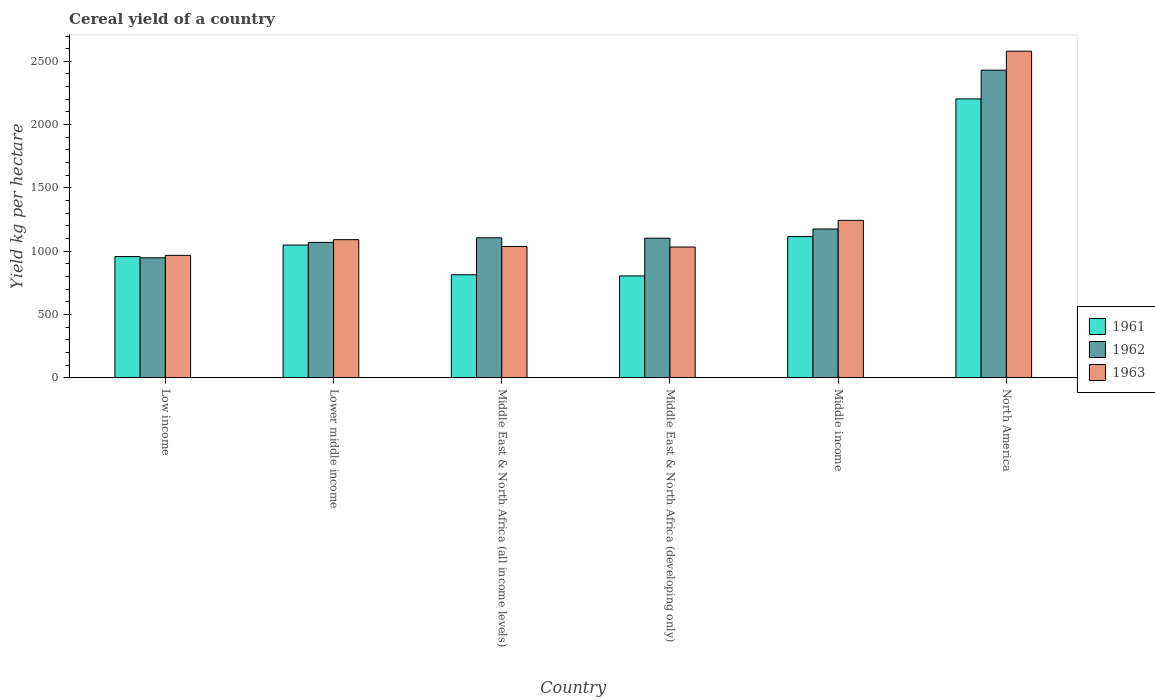How many groups of bars are there?
Give a very brief answer. 6. In how many cases, is the number of bars for a given country not equal to the number of legend labels?
Your answer should be very brief. 0. What is the total cereal yield in 1961 in Lower middle income?
Provide a succinct answer. 1048.21. Across all countries, what is the maximum total cereal yield in 1963?
Your response must be concise. 2580.19. Across all countries, what is the minimum total cereal yield in 1963?
Make the answer very short. 966.74. In which country was the total cereal yield in 1961 maximum?
Provide a short and direct response. North America. In which country was the total cereal yield in 1963 minimum?
Offer a terse response. Low income. What is the total total cereal yield in 1962 in the graph?
Offer a terse response. 7829.41. What is the difference between the total cereal yield in 1961 in Middle East & North Africa (all income levels) and that in North America?
Your answer should be very brief. -1390.13. What is the difference between the total cereal yield in 1962 in Middle income and the total cereal yield in 1963 in Middle East & North Africa (developing only)?
Provide a succinct answer. 142.79. What is the average total cereal yield in 1963 per country?
Your answer should be very brief. 1325.02. What is the difference between the total cereal yield of/in 1963 and total cereal yield of/in 1961 in North America?
Ensure brevity in your answer.  376.9. In how many countries, is the total cereal yield in 1963 greater than 200 kg per hectare?
Give a very brief answer. 6. What is the ratio of the total cereal yield in 1961 in Lower middle income to that in Middle East & North Africa (developing only)?
Offer a very short reply. 1.3. Is the difference between the total cereal yield in 1963 in Middle East & North Africa (all income levels) and North America greater than the difference between the total cereal yield in 1961 in Middle East & North Africa (all income levels) and North America?
Provide a short and direct response. No. What is the difference between the highest and the second highest total cereal yield in 1963?
Keep it short and to the point. -152.61. What is the difference between the highest and the lowest total cereal yield in 1963?
Give a very brief answer. 1613.45. In how many countries, is the total cereal yield in 1962 greater than the average total cereal yield in 1962 taken over all countries?
Your answer should be very brief. 1. Is the sum of the total cereal yield in 1963 in Low income and Middle East & North Africa (developing only) greater than the maximum total cereal yield in 1962 across all countries?
Offer a terse response. No. What does the 1st bar from the right in North America represents?
Offer a terse response. 1963. Is it the case that in every country, the sum of the total cereal yield in 1963 and total cereal yield in 1961 is greater than the total cereal yield in 1962?
Your response must be concise. Yes. How many bars are there?
Keep it short and to the point. 18. Are all the bars in the graph horizontal?
Ensure brevity in your answer.  No. How many countries are there in the graph?
Ensure brevity in your answer.  6. Are the values on the major ticks of Y-axis written in scientific E-notation?
Offer a very short reply. No. Does the graph contain grids?
Make the answer very short. No. What is the title of the graph?
Offer a very short reply. Cereal yield of a country. What is the label or title of the X-axis?
Keep it short and to the point. Country. What is the label or title of the Y-axis?
Give a very brief answer. Yield kg per hectare. What is the Yield kg per hectare in 1961 in Low income?
Keep it short and to the point. 956.88. What is the Yield kg per hectare of 1962 in Low income?
Your answer should be very brief. 947.28. What is the Yield kg per hectare of 1963 in Low income?
Offer a very short reply. 966.74. What is the Yield kg per hectare in 1961 in Lower middle income?
Provide a succinct answer. 1048.21. What is the Yield kg per hectare in 1962 in Lower middle income?
Provide a short and direct response. 1069.15. What is the Yield kg per hectare in 1963 in Lower middle income?
Provide a succinct answer. 1090.7. What is the Yield kg per hectare of 1961 in Middle East & North Africa (all income levels)?
Keep it short and to the point. 813.16. What is the Yield kg per hectare in 1962 in Middle East & North Africa (all income levels)?
Make the answer very short. 1105.39. What is the Yield kg per hectare of 1963 in Middle East & North Africa (all income levels)?
Provide a succinct answer. 1036.88. What is the Yield kg per hectare in 1961 in Middle East & North Africa (developing only)?
Offer a very short reply. 804.16. What is the Yield kg per hectare of 1962 in Middle East & North Africa (developing only)?
Your answer should be very brief. 1102.28. What is the Yield kg per hectare of 1963 in Middle East & North Africa (developing only)?
Your response must be concise. 1032.31. What is the Yield kg per hectare in 1961 in Middle income?
Provide a short and direct response. 1114.95. What is the Yield kg per hectare of 1962 in Middle income?
Offer a very short reply. 1175.1. What is the Yield kg per hectare of 1963 in Middle income?
Keep it short and to the point. 1243.31. What is the Yield kg per hectare in 1961 in North America?
Offer a terse response. 2203.29. What is the Yield kg per hectare in 1962 in North America?
Provide a short and direct response. 2430.22. What is the Yield kg per hectare of 1963 in North America?
Provide a succinct answer. 2580.19. Across all countries, what is the maximum Yield kg per hectare of 1961?
Your response must be concise. 2203.29. Across all countries, what is the maximum Yield kg per hectare in 1962?
Provide a succinct answer. 2430.22. Across all countries, what is the maximum Yield kg per hectare in 1963?
Your answer should be very brief. 2580.19. Across all countries, what is the minimum Yield kg per hectare in 1961?
Provide a short and direct response. 804.16. Across all countries, what is the minimum Yield kg per hectare in 1962?
Offer a terse response. 947.28. Across all countries, what is the minimum Yield kg per hectare in 1963?
Ensure brevity in your answer.  966.74. What is the total Yield kg per hectare in 1961 in the graph?
Provide a short and direct response. 6940.66. What is the total Yield kg per hectare in 1962 in the graph?
Your answer should be compact. 7829.41. What is the total Yield kg per hectare in 1963 in the graph?
Provide a short and direct response. 7950.14. What is the difference between the Yield kg per hectare in 1961 in Low income and that in Lower middle income?
Make the answer very short. -91.33. What is the difference between the Yield kg per hectare in 1962 in Low income and that in Lower middle income?
Give a very brief answer. -121.86. What is the difference between the Yield kg per hectare in 1963 in Low income and that in Lower middle income?
Offer a very short reply. -123.96. What is the difference between the Yield kg per hectare in 1961 in Low income and that in Middle East & North Africa (all income levels)?
Provide a short and direct response. 143.72. What is the difference between the Yield kg per hectare of 1962 in Low income and that in Middle East & North Africa (all income levels)?
Provide a succinct answer. -158.11. What is the difference between the Yield kg per hectare in 1963 in Low income and that in Middle East & North Africa (all income levels)?
Ensure brevity in your answer.  -70.14. What is the difference between the Yield kg per hectare of 1961 in Low income and that in Middle East & North Africa (developing only)?
Provide a succinct answer. 152.73. What is the difference between the Yield kg per hectare in 1962 in Low income and that in Middle East & North Africa (developing only)?
Your response must be concise. -155. What is the difference between the Yield kg per hectare of 1963 in Low income and that in Middle East & North Africa (developing only)?
Your answer should be compact. -65.56. What is the difference between the Yield kg per hectare of 1961 in Low income and that in Middle income?
Your answer should be compact. -158.06. What is the difference between the Yield kg per hectare in 1962 in Low income and that in Middle income?
Your answer should be very brief. -227.82. What is the difference between the Yield kg per hectare of 1963 in Low income and that in Middle income?
Your answer should be very brief. -276.57. What is the difference between the Yield kg per hectare of 1961 in Low income and that in North America?
Provide a succinct answer. -1246.41. What is the difference between the Yield kg per hectare of 1962 in Low income and that in North America?
Offer a very short reply. -1482.94. What is the difference between the Yield kg per hectare in 1963 in Low income and that in North America?
Provide a short and direct response. -1613.45. What is the difference between the Yield kg per hectare of 1961 in Lower middle income and that in Middle East & North Africa (all income levels)?
Your answer should be very brief. 235.05. What is the difference between the Yield kg per hectare of 1962 in Lower middle income and that in Middle East & North Africa (all income levels)?
Ensure brevity in your answer.  -36.24. What is the difference between the Yield kg per hectare in 1963 in Lower middle income and that in Middle East & North Africa (all income levels)?
Keep it short and to the point. 53.82. What is the difference between the Yield kg per hectare of 1961 in Lower middle income and that in Middle East & North Africa (developing only)?
Offer a very short reply. 244.06. What is the difference between the Yield kg per hectare in 1962 in Lower middle income and that in Middle East & North Africa (developing only)?
Ensure brevity in your answer.  -33.13. What is the difference between the Yield kg per hectare in 1963 in Lower middle income and that in Middle East & North Africa (developing only)?
Give a very brief answer. 58.39. What is the difference between the Yield kg per hectare in 1961 in Lower middle income and that in Middle income?
Offer a terse response. -66.73. What is the difference between the Yield kg per hectare in 1962 in Lower middle income and that in Middle income?
Provide a short and direct response. -105.95. What is the difference between the Yield kg per hectare in 1963 in Lower middle income and that in Middle income?
Provide a succinct answer. -152.61. What is the difference between the Yield kg per hectare of 1961 in Lower middle income and that in North America?
Provide a succinct answer. -1155.08. What is the difference between the Yield kg per hectare in 1962 in Lower middle income and that in North America?
Your answer should be compact. -1361.07. What is the difference between the Yield kg per hectare in 1963 in Lower middle income and that in North America?
Provide a succinct answer. -1489.49. What is the difference between the Yield kg per hectare of 1961 in Middle East & North Africa (all income levels) and that in Middle East & North Africa (developing only)?
Make the answer very short. 9. What is the difference between the Yield kg per hectare of 1962 in Middle East & North Africa (all income levels) and that in Middle East & North Africa (developing only)?
Provide a short and direct response. 3.11. What is the difference between the Yield kg per hectare of 1963 in Middle East & North Africa (all income levels) and that in Middle East & North Africa (developing only)?
Offer a terse response. 4.58. What is the difference between the Yield kg per hectare in 1961 in Middle East & North Africa (all income levels) and that in Middle income?
Make the answer very short. -301.78. What is the difference between the Yield kg per hectare in 1962 in Middle East & North Africa (all income levels) and that in Middle income?
Your answer should be compact. -69.71. What is the difference between the Yield kg per hectare in 1963 in Middle East & North Africa (all income levels) and that in Middle income?
Your answer should be very brief. -206.43. What is the difference between the Yield kg per hectare in 1961 in Middle East & North Africa (all income levels) and that in North America?
Your answer should be compact. -1390.13. What is the difference between the Yield kg per hectare of 1962 in Middle East & North Africa (all income levels) and that in North America?
Your answer should be compact. -1324.83. What is the difference between the Yield kg per hectare of 1963 in Middle East & North Africa (all income levels) and that in North America?
Your answer should be very brief. -1543.31. What is the difference between the Yield kg per hectare of 1961 in Middle East & North Africa (developing only) and that in Middle income?
Offer a terse response. -310.79. What is the difference between the Yield kg per hectare in 1962 in Middle East & North Africa (developing only) and that in Middle income?
Offer a very short reply. -72.82. What is the difference between the Yield kg per hectare of 1963 in Middle East & North Africa (developing only) and that in Middle income?
Your response must be concise. -211. What is the difference between the Yield kg per hectare of 1961 in Middle East & North Africa (developing only) and that in North America?
Ensure brevity in your answer.  -1399.14. What is the difference between the Yield kg per hectare in 1962 in Middle East & North Africa (developing only) and that in North America?
Keep it short and to the point. -1327.94. What is the difference between the Yield kg per hectare in 1963 in Middle East & North Africa (developing only) and that in North America?
Ensure brevity in your answer.  -1547.89. What is the difference between the Yield kg per hectare in 1961 in Middle income and that in North America?
Ensure brevity in your answer.  -1088.35. What is the difference between the Yield kg per hectare of 1962 in Middle income and that in North America?
Your response must be concise. -1255.12. What is the difference between the Yield kg per hectare of 1963 in Middle income and that in North America?
Keep it short and to the point. -1336.88. What is the difference between the Yield kg per hectare in 1961 in Low income and the Yield kg per hectare in 1962 in Lower middle income?
Offer a very short reply. -112.26. What is the difference between the Yield kg per hectare in 1961 in Low income and the Yield kg per hectare in 1963 in Lower middle income?
Your response must be concise. -133.82. What is the difference between the Yield kg per hectare of 1962 in Low income and the Yield kg per hectare of 1963 in Lower middle income?
Offer a very short reply. -143.42. What is the difference between the Yield kg per hectare of 1961 in Low income and the Yield kg per hectare of 1962 in Middle East & North Africa (all income levels)?
Keep it short and to the point. -148.5. What is the difference between the Yield kg per hectare of 1961 in Low income and the Yield kg per hectare of 1963 in Middle East & North Africa (all income levels)?
Keep it short and to the point. -80. What is the difference between the Yield kg per hectare in 1962 in Low income and the Yield kg per hectare in 1963 in Middle East & North Africa (all income levels)?
Provide a short and direct response. -89.6. What is the difference between the Yield kg per hectare in 1961 in Low income and the Yield kg per hectare in 1962 in Middle East & North Africa (developing only)?
Provide a succinct answer. -145.4. What is the difference between the Yield kg per hectare in 1961 in Low income and the Yield kg per hectare in 1963 in Middle East & North Africa (developing only)?
Provide a short and direct response. -75.42. What is the difference between the Yield kg per hectare of 1962 in Low income and the Yield kg per hectare of 1963 in Middle East & North Africa (developing only)?
Give a very brief answer. -85.03. What is the difference between the Yield kg per hectare of 1961 in Low income and the Yield kg per hectare of 1962 in Middle income?
Make the answer very short. -218.22. What is the difference between the Yield kg per hectare in 1961 in Low income and the Yield kg per hectare in 1963 in Middle income?
Keep it short and to the point. -286.43. What is the difference between the Yield kg per hectare of 1962 in Low income and the Yield kg per hectare of 1963 in Middle income?
Provide a short and direct response. -296.03. What is the difference between the Yield kg per hectare of 1961 in Low income and the Yield kg per hectare of 1962 in North America?
Your answer should be very brief. -1473.33. What is the difference between the Yield kg per hectare of 1961 in Low income and the Yield kg per hectare of 1963 in North America?
Your response must be concise. -1623.31. What is the difference between the Yield kg per hectare in 1962 in Low income and the Yield kg per hectare in 1963 in North America?
Your response must be concise. -1632.91. What is the difference between the Yield kg per hectare of 1961 in Lower middle income and the Yield kg per hectare of 1962 in Middle East & North Africa (all income levels)?
Offer a very short reply. -57.17. What is the difference between the Yield kg per hectare in 1961 in Lower middle income and the Yield kg per hectare in 1963 in Middle East & North Africa (all income levels)?
Ensure brevity in your answer.  11.33. What is the difference between the Yield kg per hectare of 1962 in Lower middle income and the Yield kg per hectare of 1963 in Middle East & North Africa (all income levels)?
Keep it short and to the point. 32.26. What is the difference between the Yield kg per hectare in 1961 in Lower middle income and the Yield kg per hectare in 1962 in Middle East & North Africa (developing only)?
Offer a terse response. -54.07. What is the difference between the Yield kg per hectare of 1961 in Lower middle income and the Yield kg per hectare of 1963 in Middle East & North Africa (developing only)?
Make the answer very short. 15.9. What is the difference between the Yield kg per hectare of 1962 in Lower middle income and the Yield kg per hectare of 1963 in Middle East & North Africa (developing only)?
Offer a very short reply. 36.84. What is the difference between the Yield kg per hectare in 1961 in Lower middle income and the Yield kg per hectare in 1962 in Middle income?
Your answer should be compact. -126.89. What is the difference between the Yield kg per hectare of 1961 in Lower middle income and the Yield kg per hectare of 1963 in Middle income?
Provide a succinct answer. -195.1. What is the difference between the Yield kg per hectare of 1962 in Lower middle income and the Yield kg per hectare of 1963 in Middle income?
Offer a terse response. -174.17. What is the difference between the Yield kg per hectare of 1961 in Lower middle income and the Yield kg per hectare of 1962 in North America?
Keep it short and to the point. -1382.01. What is the difference between the Yield kg per hectare of 1961 in Lower middle income and the Yield kg per hectare of 1963 in North America?
Offer a very short reply. -1531.98. What is the difference between the Yield kg per hectare of 1962 in Lower middle income and the Yield kg per hectare of 1963 in North America?
Provide a succinct answer. -1511.05. What is the difference between the Yield kg per hectare in 1961 in Middle East & North Africa (all income levels) and the Yield kg per hectare in 1962 in Middle East & North Africa (developing only)?
Your response must be concise. -289.12. What is the difference between the Yield kg per hectare of 1961 in Middle East & North Africa (all income levels) and the Yield kg per hectare of 1963 in Middle East & North Africa (developing only)?
Offer a terse response. -219.15. What is the difference between the Yield kg per hectare of 1962 in Middle East & North Africa (all income levels) and the Yield kg per hectare of 1963 in Middle East & North Africa (developing only)?
Give a very brief answer. 73.08. What is the difference between the Yield kg per hectare in 1961 in Middle East & North Africa (all income levels) and the Yield kg per hectare in 1962 in Middle income?
Ensure brevity in your answer.  -361.94. What is the difference between the Yield kg per hectare in 1961 in Middle East & North Africa (all income levels) and the Yield kg per hectare in 1963 in Middle income?
Provide a succinct answer. -430.15. What is the difference between the Yield kg per hectare of 1962 in Middle East & North Africa (all income levels) and the Yield kg per hectare of 1963 in Middle income?
Your response must be concise. -137.92. What is the difference between the Yield kg per hectare of 1961 in Middle East & North Africa (all income levels) and the Yield kg per hectare of 1962 in North America?
Ensure brevity in your answer.  -1617.06. What is the difference between the Yield kg per hectare in 1961 in Middle East & North Africa (all income levels) and the Yield kg per hectare in 1963 in North America?
Keep it short and to the point. -1767.03. What is the difference between the Yield kg per hectare of 1962 in Middle East & North Africa (all income levels) and the Yield kg per hectare of 1963 in North America?
Keep it short and to the point. -1474.81. What is the difference between the Yield kg per hectare in 1961 in Middle East & North Africa (developing only) and the Yield kg per hectare in 1962 in Middle income?
Keep it short and to the point. -370.94. What is the difference between the Yield kg per hectare in 1961 in Middle East & North Africa (developing only) and the Yield kg per hectare in 1963 in Middle income?
Your response must be concise. -439.15. What is the difference between the Yield kg per hectare of 1962 in Middle East & North Africa (developing only) and the Yield kg per hectare of 1963 in Middle income?
Your answer should be very brief. -141.03. What is the difference between the Yield kg per hectare of 1961 in Middle East & North Africa (developing only) and the Yield kg per hectare of 1962 in North America?
Offer a very short reply. -1626.06. What is the difference between the Yield kg per hectare of 1961 in Middle East & North Africa (developing only) and the Yield kg per hectare of 1963 in North America?
Your answer should be very brief. -1776.04. What is the difference between the Yield kg per hectare in 1962 in Middle East & North Africa (developing only) and the Yield kg per hectare in 1963 in North America?
Your response must be concise. -1477.91. What is the difference between the Yield kg per hectare in 1961 in Middle income and the Yield kg per hectare in 1962 in North America?
Offer a terse response. -1315.27. What is the difference between the Yield kg per hectare in 1961 in Middle income and the Yield kg per hectare in 1963 in North America?
Make the answer very short. -1465.25. What is the difference between the Yield kg per hectare of 1962 in Middle income and the Yield kg per hectare of 1963 in North America?
Offer a terse response. -1405.09. What is the average Yield kg per hectare in 1961 per country?
Provide a succinct answer. 1156.78. What is the average Yield kg per hectare of 1962 per country?
Ensure brevity in your answer.  1304.9. What is the average Yield kg per hectare in 1963 per country?
Your answer should be compact. 1325.02. What is the difference between the Yield kg per hectare of 1961 and Yield kg per hectare of 1962 in Low income?
Provide a succinct answer. 9.6. What is the difference between the Yield kg per hectare of 1961 and Yield kg per hectare of 1963 in Low income?
Provide a short and direct response. -9.86. What is the difference between the Yield kg per hectare of 1962 and Yield kg per hectare of 1963 in Low income?
Your response must be concise. -19.46. What is the difference between the Yield kg per hectare of 1961 and Yield kg per hectare of 1962 in Lower middle income?
Provide a succinct answer. -20.93. What is the difference between the Yield kg per hectare of 1961 and Yield kg per hectare of 1963 in Lower middle income?
Offer a terse response. -42.49. What is the difference between the Yield kg per hectare in 1962 and Yield kg per hectare in 1963 in Lower middle income?
Provide a succinct answer. -21.55. What is the difference between the Yield kg per hectare of 1961 and Yield kg per hectare of 1962 in Middle East & North Africa (all income levels)?
Your answer should be compact. -292.23. What is the difference between the Yield kg per hectare of 1961 and Yield kg per hectare of 1963 in Middle East & North Africa (all income levels)?
Give a very brief answer. -223.72. What is the difference between the Yield kg per hectare of 1962 and Yield kg per hectare of 1963 in Middle East & North Africa (all income levels)?
Offer a terse response. 68.5. What is the difference between the Yield kg per hectare in 1961 and Yield kg per hectare in 1962 in Middle East & North Africa (developing only)?
Your response must be concise. -298.12. What is the difference between the Yield kg per hectare in 1961 and Yield kg per hectare in 1963 in Middle East & North Africa (developing only)?
Your answer should be compact. -228.15. What is the difference between the Yield kg per hectare in 1962 and Yield kg per hectare in 1963 in Middle East & North Africa (developing only)?
Ensure brevity in your answer.  69.97. What is the difference between the Yield kg per hectare in 1961 and Yield kg per hectare in 1962 in Middle income?
Offer a terse response. -60.15. What is the difference between the Yield kg per hectare of 1961 and Yield kg per hectare of 1963 in Middle income?
Your answer should be compact. -128.37. What is the difference between the Yield kg per hectare in 1962 and Yield kg per hectare in 1963 in Middle income?
Ensure brevity in your answer.  -68.21. What is the difference between the Yield kg per hectare in 1961 and Yield kg per hectare in 1962 in North America?
Keep it short and to the point. -226.92. What is the difference between the Yield kg per hectare in 1961 and Yield kg per hectare in 1963 in North America?
Offer a terse response. -376.9. What is the difference between the Yield kg per hectare of 1962 and Yield kg per hectare of 1963 in North America?
Your answer should be compact. -149.98. What is the ratio of the Yield kg per hectare of 1961 in Low income to that in Lower middle income?
Your answer should be compact. 0.91. What is the ratio of the Yield kg per hectare of 1962 in Low income to that in Lower middle income?
Your answer should be very brief. 0.89. What is the ratio of the Yield kg per hectare in 1963 in Low income to that in Lower middle income?
Keep it short and to the point. 0.89. What is the ratio of the Yield kg per hectare of 1961 in Low income to that in Middle East & North Africa (all income levels)?
Provide a short and direct response. 1.18. What is the ratio of the Yield kg per hectare of 1962 in Low income to that in Middle East & North Africa (all income levels)?
Offer a terse response. 0.86. What is the ratio of the Yield kg per hectare in 1963 in Low income to that in Middle East & North Africa (all income levels)?
Your answer should be very brief. 0.93. What is the ratio of the Yield kg per hectare in 1961 in Low income to that in Middle East & North Africa (developing only)?
Provide a short and direct response. 1.19. What is the ratio of the Yield kg per hectare of 1962 in Low income to that in Middle East & North Africa (developing only)?
Provide a succinct answer. 0.86. What is the ratio of the Yield kg per hectare in 1963 in Low income to that in Middle East & North Africa (developing only)?
Your answer should be very brief. 0.94. What is the ratio of the Yield kg per hectare in 1961 in Low income to that in Middle income?
Your response must be concise. 0.86. What is the ratio of the Yield kg per hectare in 1962 in Low income to that in Middle income?
Provide a succinct answer. 0.81. What is the ratio of the Yield kg per hectare in 1963 in Low income to that in Middle income?
Provide a short and direct response. 0.78. What is the ratio of the Yield kg per hectare in 1961 in Low income to that in North America?
Offer a terse response. 0.43. What is the ratio of the Yield kg per hectare in 1962 in Low income to that in North America?
Your answer should be very brief. 0.39. What is the ratio of the Yield kg per hectare of 1963 in Low income to that in North America?
Offer a very short reply. 0.37. What is the ratio of the Yield kg per hectare in 1961 in Lower middle income to that in Middle East & North Africa (all income levels)?
Give a very brief answer. 1.29. What is the ratio of the Yield kg per hectare of 1962 in Lower middle income to that in Middle East & North Africa (all income levels)?
Give a very brief answer. 0.97. What is the ratio of the Yield kg per hectare of 1963 in Lower middle income to that in Middle East & North Africa (all income levels)?
Make the answer very short. 1.05. What is the ratio of the Yield kg per hectare of 1961 in Lower middle income to that in Middle East & North Africa (developing only)?
Your answer should be very brief. 1.3. What is the ratio of the Yield kg per hectare in 1962 in Lower middle income to that in Middle East & North Africa (developing only)?
Provide a succinct answer. 0.97. What is the ratio of the Yield kg per hectare in 1963 in Lower middle income to that in Middle East & North Africa (developing only)?
Provide a short and direct response. 1.06. What is the ratio of the Yield kg per hectare in 1961 in Lower middle income to that in Middle income?
Make the answer very short. 0.94. What is the ratio of the Yield kg per hectare of 1962 in Lower middle income to that in Middle income?
Offer a terse response. 0.91. What is the ratio of the Yield kg per hectare of 1963 in Lower middle income to that in Middle income?
Offer a very short reply. 0.88. What is the ratio of the Yield kg per hectare in 1961 in Lower middle income to that in North America?
Provide a succinct answer. 0.48. What is the ratio of the Yield kg per hectare of 1962 in Lower middle income to that in North America?
Provide a short and direct response. 0.44. What is the ratio of the Yield kg per hectare of 1963 in Lower middle income to that in North America?
Your answer should be very brief. 0.42. What is the ratio of the Yield kg per hectare in 1961 in Middle East & North Africa (all income levels) to that in Middle East & North Africa (developing only)?
Your answer should be very brief. 1.01. What is the ratio of the Yield kg per hectare of 1962 in Middle East & North Africa (all income levels) to that in Middle East & North Africa (developing only)?
Your response must be concise. 1. What is the ratio of the Yield kg per hectare of 1963 in Middle East & North Africa (all income levels) to that in Middle East & North Africa (developing only)?
Your answer should be very brief. 1. What is the ratio of the Yield kg per hectare in 1961 in Middle East & North Africa (all income levels) to that in Middle income?
Offer a terse response. 0.73. What is the ratio of the Yield kg per hectare of 1962 in Middle East & North Africa (all income levels) to that in Middle income?
Ensure brevity in your answer.  0.94. What is the ratio of the Yield kg per hectare of 1963 in Middle East & North Africa (all income levels) to that in Middle income?
Your answer should be compact. 0.83. What is the ratio of the Yield kg per hectare in 1961 in Middle East & North Africa (all income levels) to that in North America?
Your answer should be very brief. 0.37. What is the ratio of the Yield kg per hectare of 1962 in Middle East & North Africa (all income levels) to that in North America?
Provide a short and direct response. 0.45. What is the ratio of the Yield kg per hectare of 1963 in Middle East & North Africa (all income levels) to that in North America?
Your answer should be very brief. 0.4. What is the ratio of the Yield kg per hectare of 1961 in Middle East & North Africa (developing only) to that in Middle income?
Offer a very short reply. 0.72. What is the ratio of the Yield kg per hectare in 1962 in Middle East & North Africa (developing only) to that in Middle income?
Your response must be concise. 0.94. What is the ratio of the Yield kg per hectare in 1963 in Middle East & North Africa (developing only) to that in Middle income?
Your response must be concise. 0.83. What is the ratio of the Yield kg per hectare in 1961 in Middle East & North Africa (developing only) to that in North America?
Give a very brief answer. 0.36. What is the ratio of the Yield kg per hectare in 1962 in Middle East & North Africa (developing only) to that in North America?
Offer a terse response. 0.45. What is the ratio of the Yield kg per hectare in 1963 in Middle East & North Africa (developing only) to that in North America?
Keep it short and to the point. 0.4. What is the ratio of the Yield kg per hectare of 1961 in Middle income to that in North America?
Your answer should be very brief. 0.51. What is the ratio of the Yield kg per hectare in 1962 in Middle income to that in North America?
Ensure brevity in your answer.  0.48. What is the ratio of the Yield kg per hectare of 1963 in Middle income to that in North America?
Your answer should be compact. 0.48. What is the difference between the highest and the second highest Yield kg per hectare in 1961?
Offer a terse response. 1088.35. What is the difference between the highest and the second highest Yield kg per hectare of 1962?
Keep it short and to the point. 1255.12. What is the difference between the highest and the second highest Yield kg per hectare of 1963?
Offer a terse response. 1336.88. What is the difference between the highest and the lowest Yield kg per hectare of 1961?
Your answer should be compact. 1399.14. What is the difference between the highest and the lowest Yield kg per hectare of 1962?
Provide a short and direct response. 1482.94. What is the difference between the highest and the lowest Yield kg per hectare in 1963?
Your response must be concise. 1613.45. 